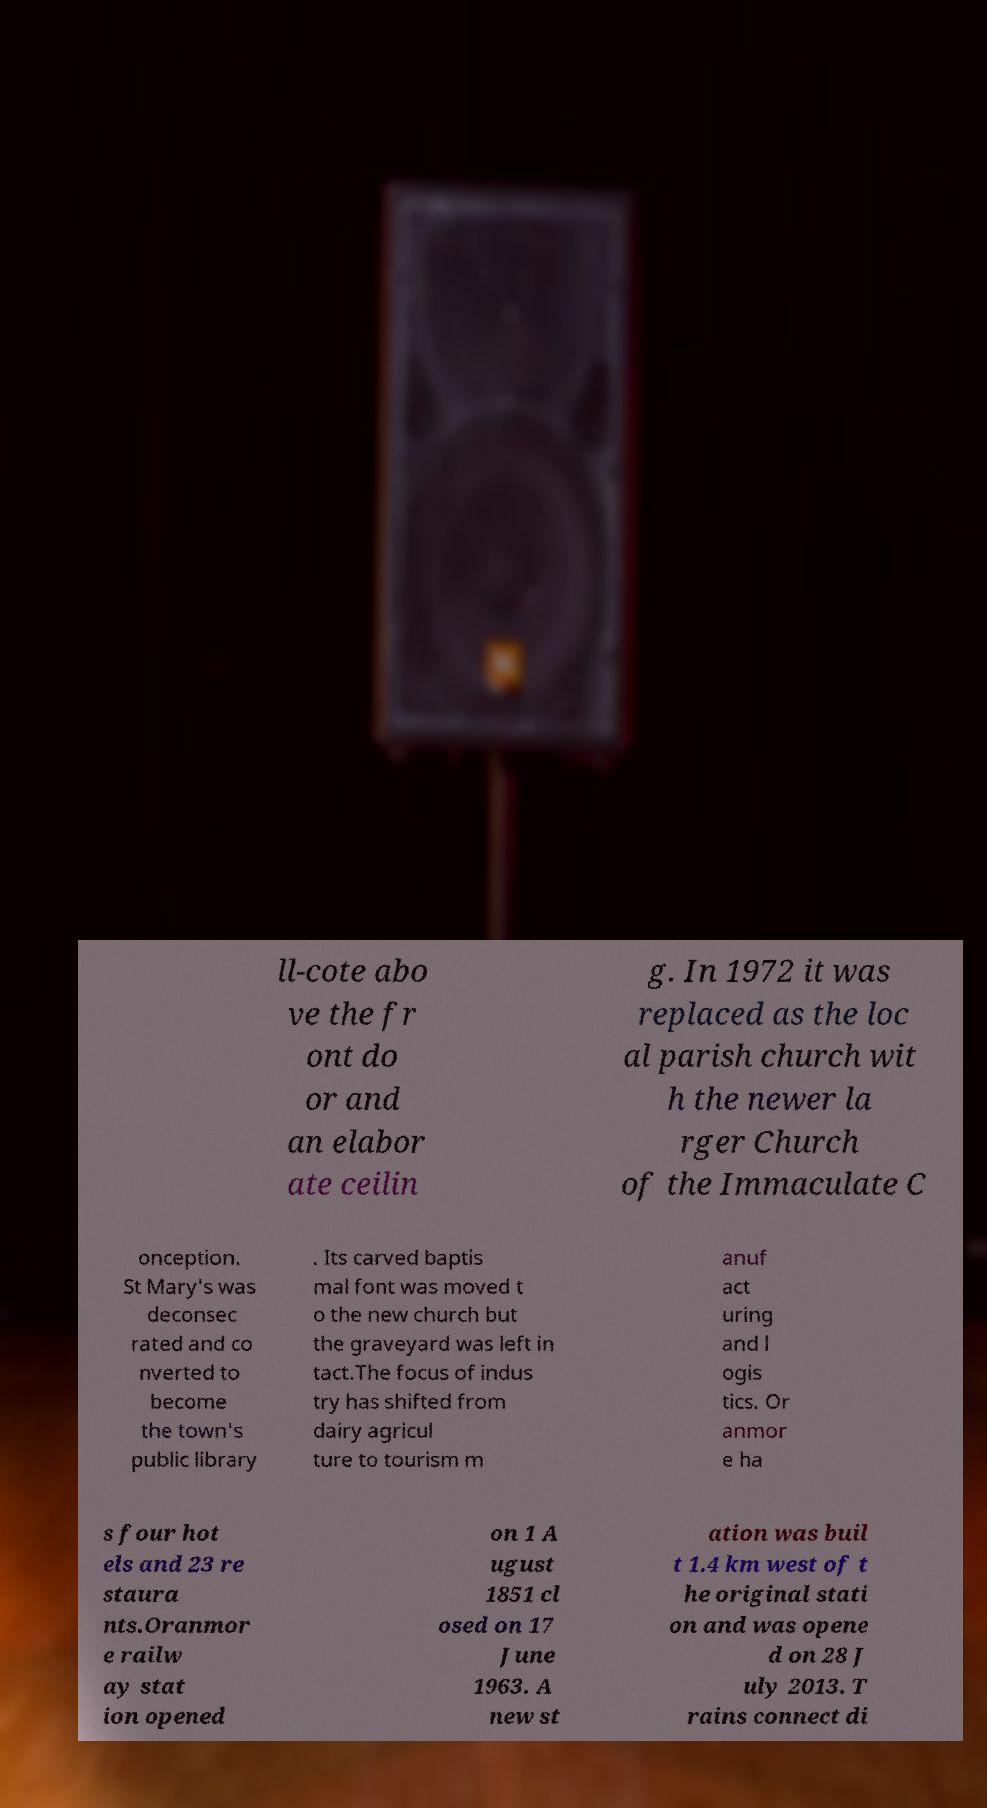Please read and relay the text visible in this image. What does it say? ll-cote abo ve the fr ont do or and an elabor ate ceilin g. In 1972 it was replaced as the loc al parish church wit h the newer la rger Church of the Immaculate C onception. St Mary's was deconsec rated and co nverted to become the town's public library . Its carved baptis mal font was moved t o the new church but the graveyard was left in tact.The focus of indus try has shifted from dairy agricul ture to tourism m anuf act uring and l ogis tics. Or anmor e ha s four hot els and 23 re staura nts.Oranmor e railw ay stat ion opened on 1 A ugust 1851 cl osed on 17 June 1963. A new st ation was buil t 1.4 km west of t he original stati on and was opene d on 28 J uly 2013. T rains connect di 